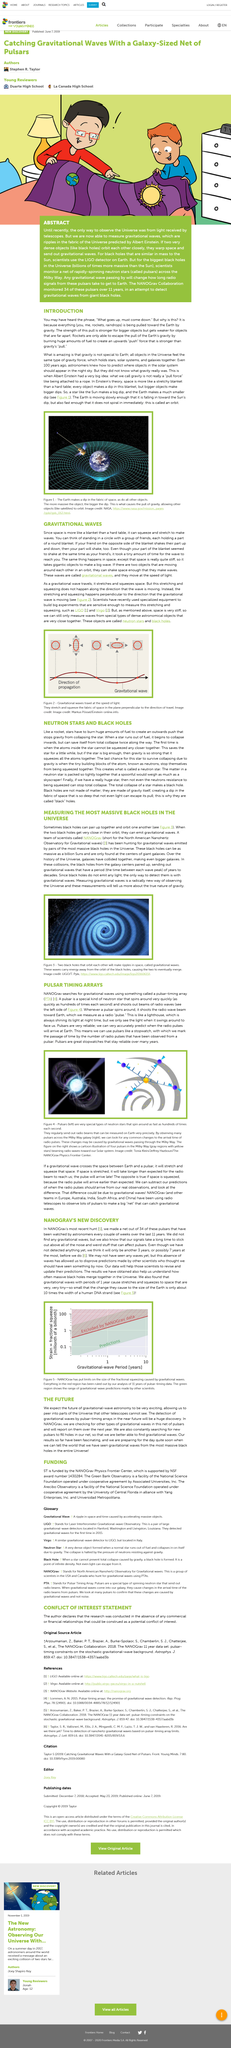Give some essential details in this illustration. NANOGrav is an acronym that stands for North American Nanohertz Observatory for Gravitational waves. Pulsars emit radio beams that can be measured on Earth. The left image displays a pulsar neutron star, which is a type of neutron star that emits beams of electromagnetic radiation. The topic of discussion is the merging of black holes. The observation has been ongoing for 11 years. 